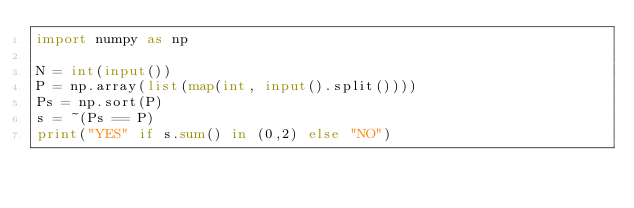Convert code to text. <code><loc_0><loc_0><loc_500><loc_500><_Python_>import numpy as np

N = int(input())
P = np.array(list(map(int, input().split())))
Ps = np.sort(P)
s = ~(Ps == P)
print("YES" if s.sum() in (0,2) else "NO")</code> 